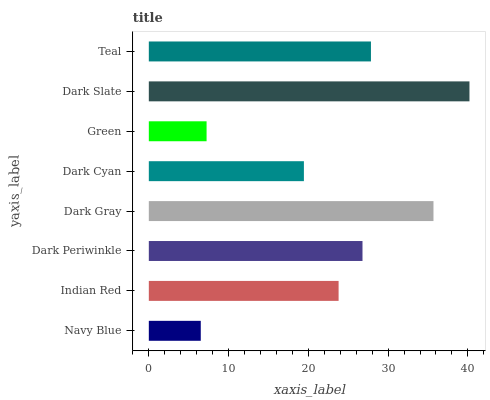Is Navy Blue the minimum?
Answer yes or no. Yes. Is Dark Slate the maximum?
Answer yes or no. Yes. Is Indian Red the minimum?
Answer yes or no. No. Is Indian Red the maximum?
Answer yes or no. No. Is Indian Red greater than Navy Blue?
Answer yes or no. Yes. Is Navy Blue less than Indian Red?
Answer yes or no. Yes. Is Navy Blue greater than Indian Red?
Answer yes or no. No. Is Indian Red less than Navy Blue?
Answer yes or no. No. Is Dark Periwinkle the high median?
Answer yes or no. Yes. Is Indian Red the low median?
Answer yes or no. Yes. Is Dark Cyan the high median?
Answer yes or no. No. Is Navy Blue the low median?
Answer yes or no. No. 